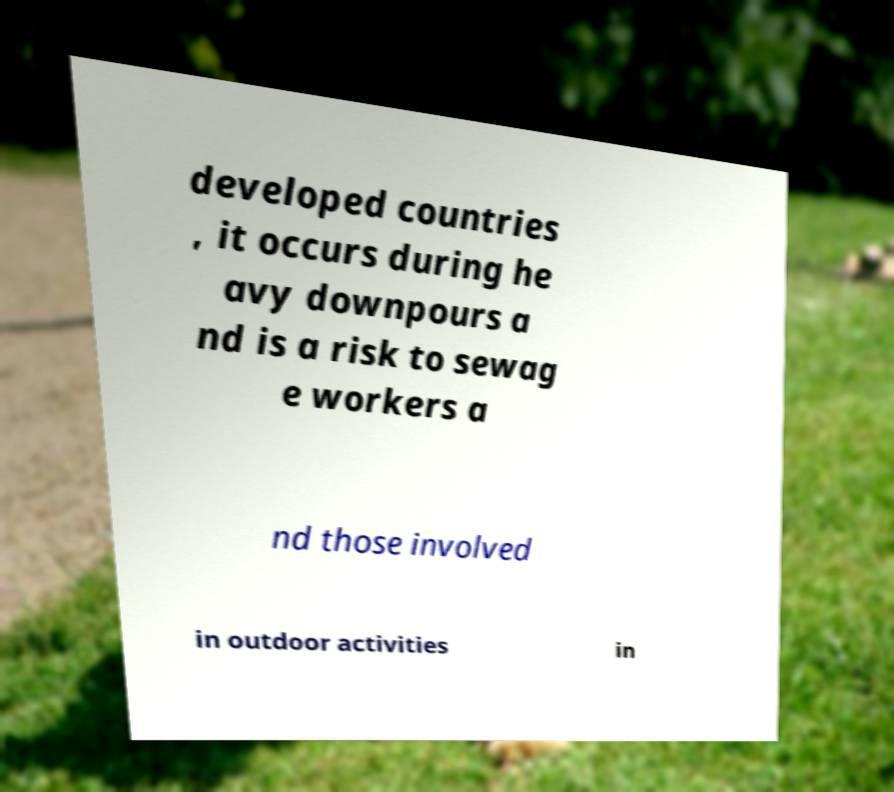I need the written content from this picture converted into text. Can you do that? developed countries , it occurs during he avy downpours a nd is a risk to sewag e workers a nd those involved in outdoor activities in 